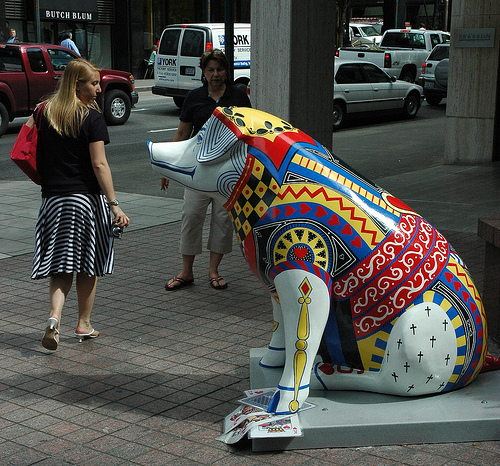<image>
Is there a person on the statue? No. The person is not positioned on the statue. They may be near each other, but the person is not supported by or resting on top of the statue. 